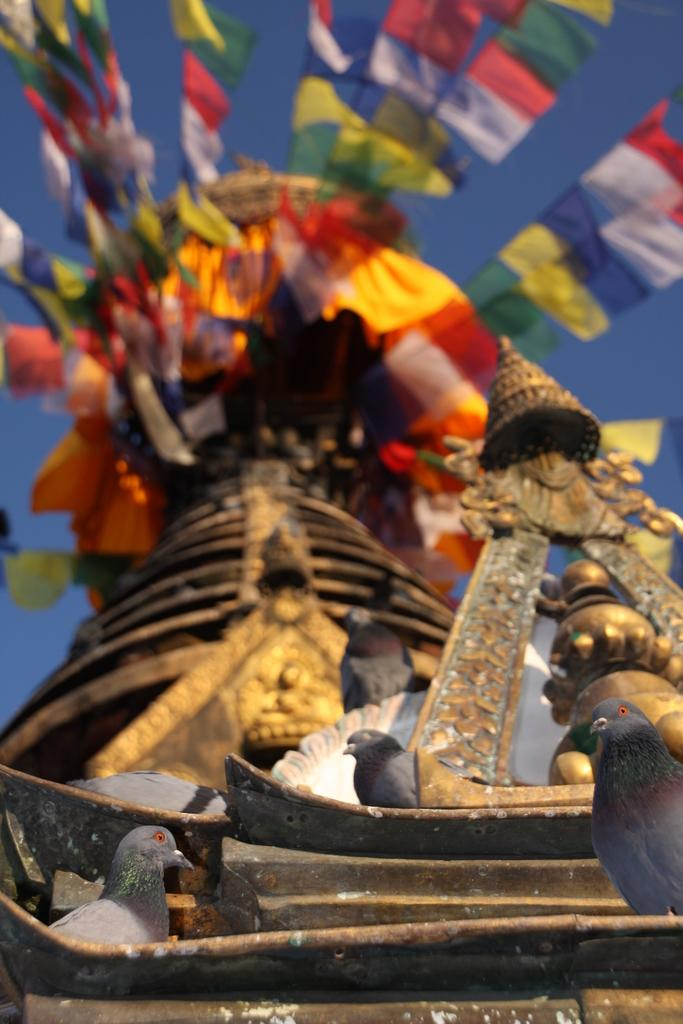What animals are present on the sculpture in the image? There are pigeons on the sculpture. What other objects can be seen on or near the sculpture? There are flags on the top of something, presumably the sculpture or a nearby structure. What type of match can be seen being used by the pigeons in the image? There is no match present in the image, and the pigeons are not using any objects. What is the pigeons' favorite type of eggnog in the image? There is no indication of the pigeons' preferences or the presence of eggnog in the image. 